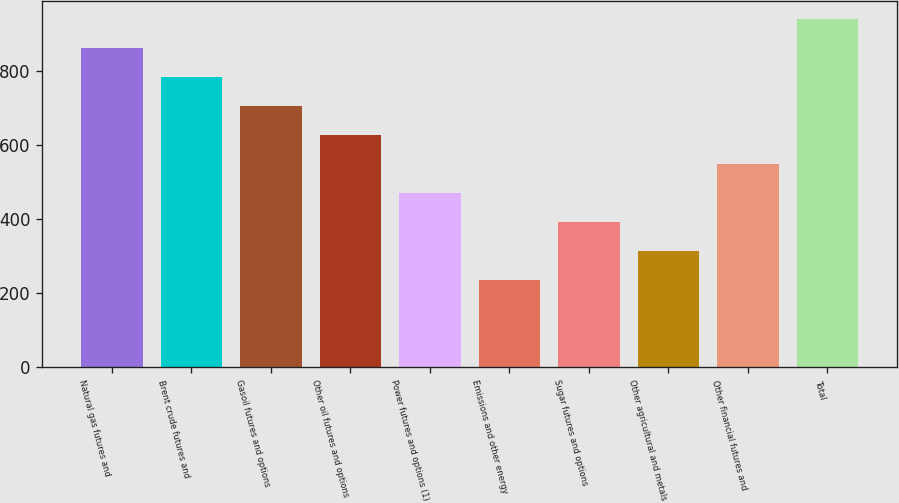Convert chart to OTSL. <chart><loc_0><loc_0><loc_500><loc_500><bar_chart><fcel>Natural gas futures and<fcel>Brent crude futures and<fcel>Gasoil futures and options<fcel>Other oil futures and options<fcel>Power futures and options (1)<fcel>Emissions and other energy<fcel>Sugar futures and options<fcel>Other agricultural and metals<fcel>Other financial futures and<fcel>Total<nl><fcel>863.39<fcel>784.99<fcel>706.58<fcel>628.18<fcel>471.38<fcel>236.16<fcel>392.97<fcel>314.56<fcel>549.78<fcel>941.79<nl></chart> 